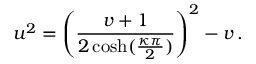Convert formula to latex. <formula><loc_0><loc_0><loc_500><loc_500>u ^ { 2 } = \left ( \frac { v + 1 } { 2 \cosh ( \frac { \kappa \pi } { 2 } ) } \right ) ^ { 2 } - v \, .</formula> 